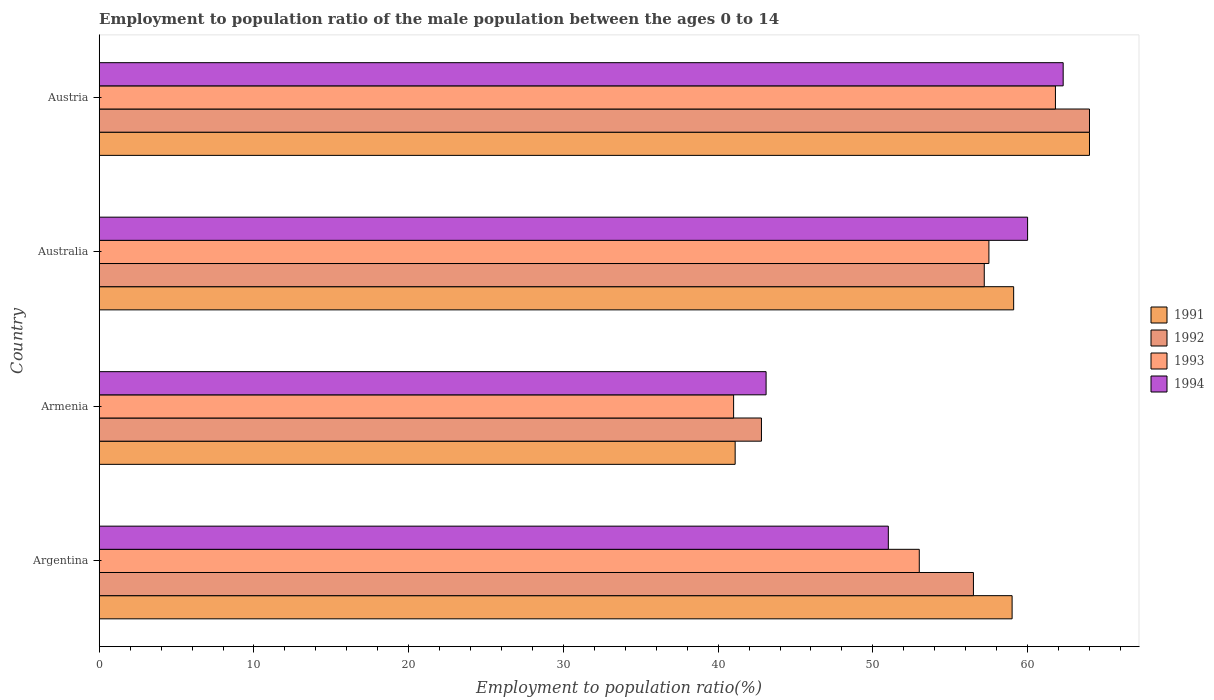How many different coloured bars are there?
Your answer should be very brief. 4. How many groups of bars are there?
Ensure brevity in your answer.  4. Are the number of bars per tick equal to the number of legend labels?
Make the answer very short. Yes. How many bars are there on the 1st tick from the top?
Your response must be concise. 4. How many bars are there on the 1st tick from the bottom?
Make the answer very short. 4. In how many cases, is the number of bars for a given country not equal to the number of legend labels?
Provide a succinct answer. 0. What is the employment to population ratio in 1992 in Argentina?
Ensure brevity in your answer.  56.5. Across all countries, what is the minimum employment to population ratio in 1994?
Make the answer very short. 43.1. In which country was the employment to population ratio in 1993 minimum?
Provide a succinct answer. Armenia. What is the total employment to population ratio in 1992 in the graph?
Provide a succinct answer. 220.5. What is the difference between the employment to population ratio in 1991 in Australia and that in Austria?
Ensure brevity in your answer.  -4.9. What is the difference between the employment to population ratio in 1994 in Austria and the employment to population ratio in 1991 in Armenia?
Your response must be concise. 21.2. What is the average employment to population ratio in 1994 per country?
Offer a very short reply. 54.1. What is the difference between the employment to population ratio in 1994 and employment to population ratio in 1992 in Argentina?
Make the answer very short. -5.5. In how many countries, is the employment to population ratio in 1992 greater than 20 %?
Your answer should be very brief. 4. Is the difference between the employment to population ratio in 1994 in Argentina and Armenia greater than the difference between the employment to population ratio in 1992 in Argentina and Armenia?
Offer a terse response. No. What is the difference between the highest and the second highest employment to population ratio in 1993?
Your answer should be compact. 4.3. What is the difference between the highest and the lowest employment to population ratio in 1993?
Ensure brevity in your answer.  20.8. In how many countries, is the employment to population ratio in 1994 greater than the average employment to population ratio in 1994 taken over all countries?
Ensure brevity in your answer.  2. Is the sum of the employment to population ratio in 1994 in Armenia and Australia greater than the maximum employment to population ratio in 1991 across all countries?
Give a very brief answer. Yes. What does the 1st bar from the bottom in Austria represents?
Your answer should be compact. 1991. Is it the case that in every country, the sum of the employment to population ratio in 1991 and employment to population ratio in 1992 is greater than the employment to population ratio in 1994?
Your answer should be very brief. Yes. How many bars are there?
Offer a very short reply. 16. Are all the bars in the graph horizontal?
Make the answer very short. Yes. How many countries are there in the graph?
Give a very brief answer. 4. Does the graph contain any zero values?
Provide a succinct answer. No. How are the legend labels stacked?
Offer a terse response. Vertical. What is the title of the graph?
Offer a very short reply. Employment to population ratio of the male population between the ages 0 to 14. Does "1980" appear as one of the legend labels in the graph?
Ensure brevity in your answer.  No. What is the label or title of the X-axis?
Your answer should be very brief. Employment to population ratio(%). What is the label or title of the Y-axis?
Your answer should be very brief. Country. What is the Employment to population ratio(%) of 1991 in Argentina?
Keep it short and to the point. 59. What is the Employment to population ratio(%) in 1992 in Argentina?
Provide a short and direct response. 56.5. What is the Employment to population ratio(%) of 1991 in Armenia?
Make the answer very short. 41.1. What is the Employment to population ratio(%) of 1992 in Armenia?
Provide a succinct answer. 42.8. What is the Employment to population ratio(%) of 1993 in Armenia?
Your response must be concise. 41. What is the Employment to population ratio(%) in 1994 in Armenia?
Provide a succinct answer. 43.1. What is the Employment to population ratio(%) in 1991 in Australia?
Provide a short and direct response. 59.1. What is the Employment to population ratio(%) in 1992 in Australia?
Offer a terse response. 57.2. What is the Employment to population ratio(%) in 1993 in Australia?
Keep it short and to the point. 57.5. What is the Employment to population ratio(%) in 1994 in Australia?
Offer a terse response. 60. What is the Employment to population ratio(%) of 1993 in Austria?
Offer a terse response. 61.8. What is the Employment to population ratio(%) in 1994 in Austria?
Provide a succinct answer. 62.3. Across all countries, what is the maximum Employment to population ratio(%) in 1991?
Give a very brief answer. 64. Across all countries, what is the maximum Employment to population ratio(%) of 1992?
Ensure brevity in your answer.  64. Across all countries, what is the maximum Employment to population ratio(%) of 1993?
Offer a terse response. 61.8. Across all countries, what is the maximum Employment to population ratio(%) of 1994?
Make the answer very short. 62.3. Across all countries, what is the minimum Employment to population ratio(%) of 1991?
Keep it short and to the point. 41.1. Across all countries, what is the minimum Employment to population ratio(%) in 1992?
Your answer should be compact. 42.8. Across all countries, what is the minimum Employment to population ratio(%) in 1993?
Your answer should be compact. 41. Across all countries, what is the minimum Employment to population ratio(%) of 1994?
Your answer should be very brief. 43.1. What is the total Employment to population ratio(%) of 1991 in the graph?
Your answer should be compact. 223.2. What is the total Employment to population ratio(%) in 1992 in the graph?
Ensure brevity in your answer.  220.5. What is the total Employment to population ratio(%) in 1993 in the graph?
Offer a terse response. 213.3. What is the total Employment to population ratio(%) of 1994 in the graph?
Your answer should be compact. 216.4. What is the difference between the Employment to population ratio(%) in 1991 in Argentina and that in Armenia?
Your answer should be very brief. 17.9. What is the difference between the Employment to population ratio(%) in 1993 in Argentina and that in Armenia?
Your answer should be very brief. 12. What is the difference between the Employment to population ratio(%) in 1994 in Argentina and that in Armenia?
Give a very brief answer. 7.9. What is the difference between the Employment to population ratio(%) of 1993 in Argentina and that in Australia?
Provide a succinct answer. -4.5. What is the difference between the Employment to population ratio(%) of 1992 in Argentina and that in Austria?
Offer a terse response. -7.5. What is the difference between the Employment to population ratio(%) of 1993 in Argentina and that in Austria?
Provide a short and direct response. -8.8. What is the difference between the Employment to population ratio(%) in 1994 in Argentina and that in Austria?
Your answer should be compact. -11.3. What is the difference between the Employment to population ratio(%) in 1991 in Armenia and that in Australia?
Make the answer very short. -18. What is the difference between the Employment to population ratio(%) in 1992 in Armenia and that in Australia?
Make the answer very short. -14.4. What is the difference between the Employment to population ratio(%) of 1993 in Armenia and that in Australia?
Offer a very short reply. -16.5. What is the difference between the Employment to population ratio(%) in 1994 in Armenia and that in Australia?
Provide a short and direct response. -16.9. What is the difference between the Employment to population ratio(%) in 1991 in Armenia and that in Austria?
Provide a succinct answer. -22.9. What is the difference between the Employment to population ratio(%) of 1992 in Armenia and that in Austria?
Your answer should be very brief. -21.2. What is the difference between the Employment to population ratio(%) of 1993 in Armenia and that in Austria?
Your response must be concise. -20.8. What is the difference between the Employment to population ratio(%) in 1994 in Armenia and that in Austria?
Offer a very short reply. -19.2. What is the difference between the Employment to population ratio(%) of 1993 in Australia and that in Austria?
Your answer should be compact. -4.3. What is the difference between the Employment to population ratio(%) in 1991 in Argentina and the Employment to population ratio(%) in 1993 in Armenia?
Offer a terse response. 18. What is the difference between the Employment to population ratio(%) in 1991 in Argentina and the Employment to population ratio(%) in 1994 in Armenia?
Your response must be concise. 15.9. What is the difference between the Employment to population ratio(%) of 1992 in Argentina and the Employment to population ratio(%) of 1993 in Armenia?
Offer a very short reply. 15.5. What is the difference between the Employment to population ratio(%) of 1992 in Argentina and the Employment to population ratio(%) of 1993 in Australia?
Give a very brief answer. -1. What is the difference between the Employment to population ratio(%) of 1992 in Argentina and the Employment to population ratio(%) of 1994 in Australia?
Give a very brief answer. -3.5. What is the difference between the Employment to population ratio(%) of 1991 in Argentina and the Employment to population ratio(%) of 1992 in Austria?
Make the answer very short. -5. What is the difference between the Employment to population ratio(%) of 1991 in Argentina and the Employment to population ratio(%) of 1993 in Austria?
Ensure brevity in your answer.  -2.8. What is the difference between the Employment to population ratio(%) in 1992 in Argentina and the Employment to population ratio(%) in 1994 in Austria?
Ensure brevity in your answer.  -5.8. What is the difference between the Employment to population ratio(%) in 1991 in Armenia and the Employment to population ratio(%) in 1992 in Australia?
Keep it short and to the point. -16.1. What is the difference between the Employment to population ratio(%) in 1991 in Armenia and the Employment to population ratio(%) in 1993 in Australia?
Offer a terse response. -16.4. What is the difference between the Employment to population ratio(%) in 1991 in Armenia and the Employment to population ratio(%) in 1994 in Australia?
Provide a succinct answer. -18.9. What is the difference between the Employment to population ratio(%) in 1992 in Armenia and the Employment to population ratio(%) in 1993 in Australia?
Your answer should be very brief. -14.7. What is the difference between the Employment to population ratio(%) of 1992 in Armenia and the Employment to population ratio(%) of 1994 in Australia?
Make the answer very short. -17.2. What is the difference between the Employment to population ratio(%) in 1991 in Armenia and the Employment to population ratio(%) in 1992 in Austria?
Ensure brevity in your answer.  -22.9. What is the difference between the Employment to population ratio(%) in 1991 in Armenia and the Employment to population ratio(%) in 1993 in Austria?
Offer a very short reply. -20.7. What is the difference between the Employment to population ratio(%) of 1991 in Armenia and the Employment to population ratio(%) of 1994 in Austria?
Provide a short and direct response. -21.2. What is the difference between the Employment to population ratio(%) in 1992 in Armenia and the Employment to population ratio(%) in 1993 in Austria?
Your answer should be compact. -19. What is the difference between the Employment to population ratio(%) in 1992 in Armenia and the Employment to population ratio(%) in 1994 in Austria?
Give a very brief answer. -19.5. What is the difference between the Employment to population ratio(%) in 1993 in Armenia and the Employment to population ratio(%) in 1994 in Austria?
Ensure brevity in your answer.  -21.3. What is the difference between the Employment to population ratio(%) in 1992 in Australia and the Employment to population ratio(%) in 1993 in Austria?
Give a very brief answer. -4.6. What is the average Employment to population ratio(%) of 1991 per country?
Provide a succinct answer. 55.8. What is the average Employment to population ratio(%) of 1992 per country?
Provide a short and direct response. 55.12. What is the average Employment to population ratio(%) of 1993 per country?
Offer a very short reply. 53.33. What is the average Employment to population ratio(%) of 1994 per country?
Give a very brief answer. 54.1. What is the difference between the Employment to population ratio(%) of 1991 and Employment to population ratio(%) of 1992 in Argentina?
Give a very brief answer. 2.5. What is the difference between the Employment to population ratio(%) of 1991 and Employment to population ratio(%) of 1993 in Argentina?
Offer a very short reply. 6. What is the difference between the Employment to population ratio(%) in 1991 and Employment to population ratio(%) in 1994 in Argentina?
Ensure brevity in your answer.  8. What is the difference between the Employment to population ratio(%) in 1992 and Employment to population ratio(%) in 1993 in Argentina?
Keep it short and to the point. 3.5. What is the difference between the Employment to population ratio(%) of 1992 and Employment to population ratio(%) of 1994 in Argentina?
Give a very brief answer. 5.5. What is the difference between the Employment to population ratio(%) of 1993 and Employment to population ratio(%) of 1994 in Argentina?
Your response must be concise. 2. What is the difference between the Employment to population ratio(%) in 1991 and Employment to population ratio(%) in 1992 in Armenia?
Provide a short and direct response. -1.7. What is the difference between the Employment to population ratio(%) in 1992 and Employment to population ratio(%) in 1993 in Armenia?
Your answer should be compact. 1.8. What is the difference between the Employment to population ratio(%) in 1992 and Employment to population ratio(%) in 1994 in Armenia?
Offer a terse response. -0.3. What is the difference between the Employment to population ratio(%) of 1991 and Employment to population ratio(%) of 1992 in Australia?
Your answer should be very brief. 1.9. What is the difference between the Employment to population ratio(%) of 1991 and Employment to population ratio(%) of 1994 in Australia?
Make the answer very short. -0.9. What is the difference between the Employment to population ratio(%) in 1993 and Employment to population ratio(%) in 1994 in Australia?
Offer a terse response. -2.5. What is the difference between the Employment to population ratio(%) of 1991 and Employment to population ratio(%) of 1992 in Austria?
Give a very brief answer. 0. What is the difference between the Employment to population ratio(%) in 1991 and Employment to population ratio(%) in 1994 in Austria?
Your answer should be very brief. 1.7. What is the difference between the Employment to population ratio(%) of 1992 and Employment to population ratio(%) of 1993 in Austria?
Keep it short and to the point. 2.2. What is the difference between the Employment to population ratio(%) in 1992 and Employment to population ratio(%) in 1994 in Austria?
Provide a short and direct response. 1.7. What is the difference between the Employment to population ratio(%) of 1993 and Employment to population ratio(%) of 1994 in Austria?
Make the answer very short. -0.5. What is the ratio of the Employment to population ratio(%) in 1991 in Argentina to that in Armenia?
Provide a succinct answer. 1.44. What is the ratio of the Employment to population ratio(%) of 1992 in Argentina to that in Armenia?
Offer a very short reply. 1.32. What is the ratio of the Employment to population ratio(%) of 1993 in Argentina to that in Armenia?
Your answer should be very brief. 1.29. What is the ratio of the Employment to population ratio(%) in 1994 in Argentina to that in Armenia?
Give a very brief answer. 1.18. What is the ratio of the Employment to population ratio(%) of 1991 in Argentina to that in Australia?
Ensure brevity in your answer.  1. What is the ratio of the Employment to population ratio(%) in 1992 in Argentina to that in Australia?
Your response must be concise. 0.99. What is the ratio of the Employment to population ratio(%) in 1993 in Argentina to that in Australia?
Offer a very short reply. 0.92. What is the ratio of the Employment to population ratio(%) in 1991 in Argentina to that in Austria?
Offer a terse response. 0.92. What is the ratio of the Employment to population ratio(%) of 1992 in Argentina to that in Austria?
Ensure brevity in your answer.  0.88. What is the ratio of the Employment to population ratio(%) of 1993 in Argentina to that in Austria?
Your answer should be very brief. 0.86. What is the ratio of the Employment to population ratio(%) of 1994 in Argentina to that in Austria?
Offer a very short reply. 0.82. What is the ratio of the Employment to population ratio(%) of 1991 in Armenia to that in Australia?
Offer a terse response. 0.7. What is the ratio of the Employment to population ratio(%) in 1992 in Armenia to that in Australia?
Provide a succinct answer. 0.75. What is the ratio of the Employment to population ratio(%) in 1993 in Armenia to that in Australia?
Offer a terse response. 0.71. What is the ratio of the Employment to population ratio(%) in 1994 in Armenia to that in Australia?
Keep it short and to the point. 0.72. What is the ratio of the Employment to population ratio(%) in 1991 in Armenia to that in Austria?
Your answer should be very brief. 0.64. What is the ratio of the Employment to population ratio(%) in 1992 in Armenia to that in Austria?
Provide a succinct answer. 0.67. What is the ratio of the Employment to population ratio(%) in 1993 in Armenia to that in Austria?
Make the answer very short. 0.66. What is the ratio of the Employment to population ratio(%) in 1994 in Armenia to that in Austria?
Ensure brevity in your answer.  0.69. What is the ratio of the Employment to population ratio(%) in 1991 in Australia to that in Austria?
Offer a terse response. 0.92. What is the ratio of the Employment to population ratio(%) in 1992 in Australia to that in Austria?
Give a very brief answer. 0.89. What is the ratio of the Employment to population ratio(%) of 1993 in Australia to that in Austria?
Your answer should be very brief. 0.93. What is the ratio of the Employment to population ratio(%) in 1994 in Australia to that in Austria?
Ensure brevity in your answer.  0.96. What is the difference between the highest and the second highest Employment to population ratio(%) of 1991?
Ensure brevity in your answer.  4.9. What is the difference between the highest and the second highest Employment to population ratio(%) in 1992?
Offer a terse response. 6.8. What is the difference between the highest and the lowest Employment to population ratio(%) of 1991?
Offer a very short reply. 22.9. What is the difference between the highest and the lowest Employment to population ratio(%) in 1992?
Your answer should be very brief. 21.2. What is the difference between the highest and the lowest Employment to population ratio(%) in 1993?
Your response must be concise. 20.8. What is the difference between the highest and the lowest Employment to population ratio(%) of 1994?
Offer a very short reply. 19.2. 